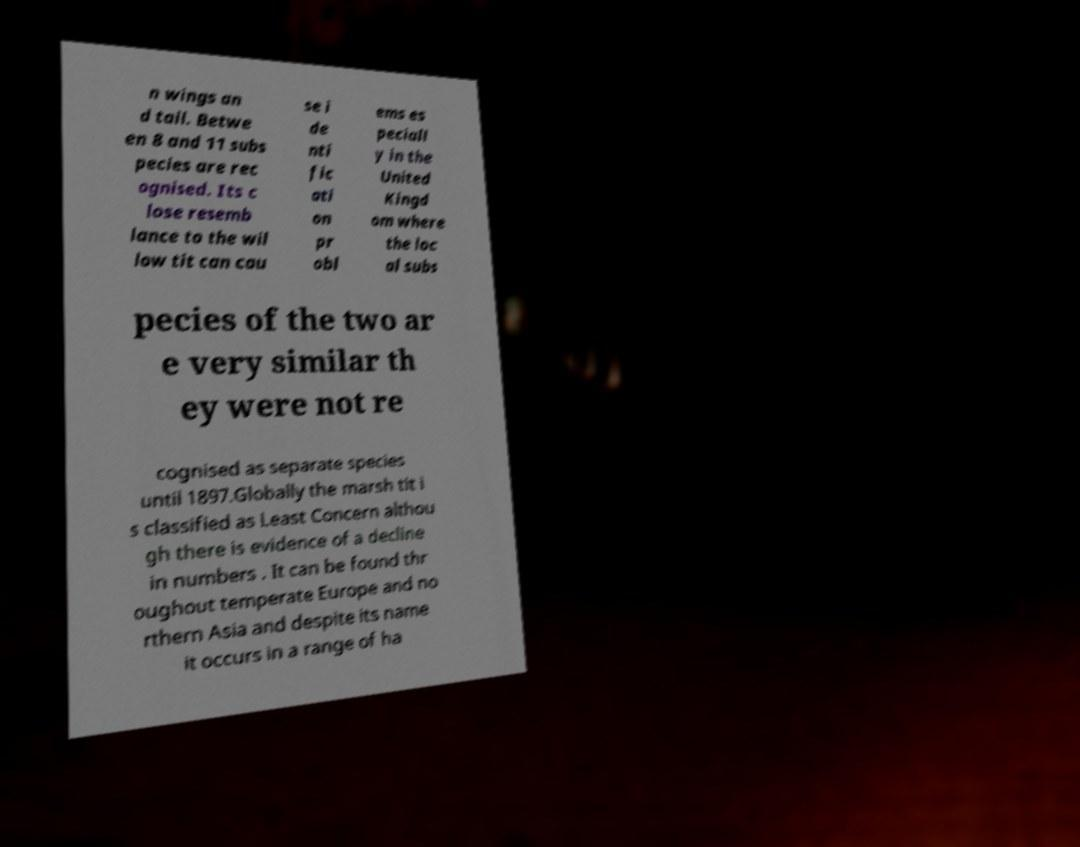For documentation purposes, I need the text within this image transcribed. Could you provide that? n wings an d tail. Betwe en 8 and 11 subs pecies are rec ognised. Its c lose resemb lance to the wil low tit can cau se i de nti fic ati on pr obl ems es peciall y in the United Kingd om where the loc al subs pecies of the two ar e very similar th ey were not re cognised as separate species until 1897.Globally the marsh tit i s classified as Least Concern althou gh there is evidence of a decline in numbers . It can be found thr oughout temperate Europe and no rthern Asia and despite its name it occurs in a range of ha 